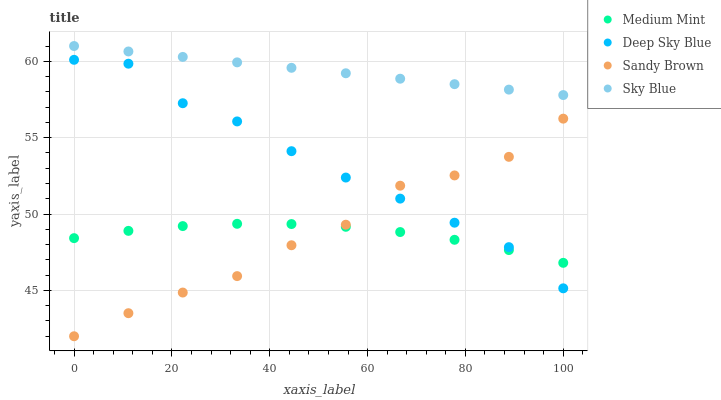Does Medium Mint have the minimum area under the curve?
Answer yes or no. Yes. Does Sky Blue have the maximum area under the curve?
Answer yes or no. Yes. Does Sandy Brown have the minimum area under the curve?
Answer yes or no. No. Does Sandy Brown have the maximum area under the curve?
Answer yes or no. No. Is Sky Blue the smoothest?
Answer yes or no. Yes. Is Sandy Brown the roughest?
Answer yes or no. Yes. Is Sandy Brown the smoothest?
Answer yes or no. No. Is Sky Blue the roughest?
Answer yes or no. No. Does Sandy Brown have the lowest value?
Answer yes or no. Yes. Does Sky Blue have the lowest value?
Answer yes or no. No. Does Sky Blue have the highest value?
Answer yes or no. Yes. Does Sandy Brown have the highest value?
Answer yes or no. No. Is Medium Mint less than Sky Blue?
Answer yes or no. Yes. Is Sky Blue greater than Medium Mint?
Answer yes or no. Yes. Does Deep Sky Blue intersect Sandy Brown?
Answer yes or no. Yes. Is Deep Sky Blue less than Sandy Brown?
Answer yes or no. No. Is Deep Sky Blue greater than Sandy Brown?
Answer yes or no. No. Does Medium Mint intersect Sky Blue?
Answer yes or no. No. 